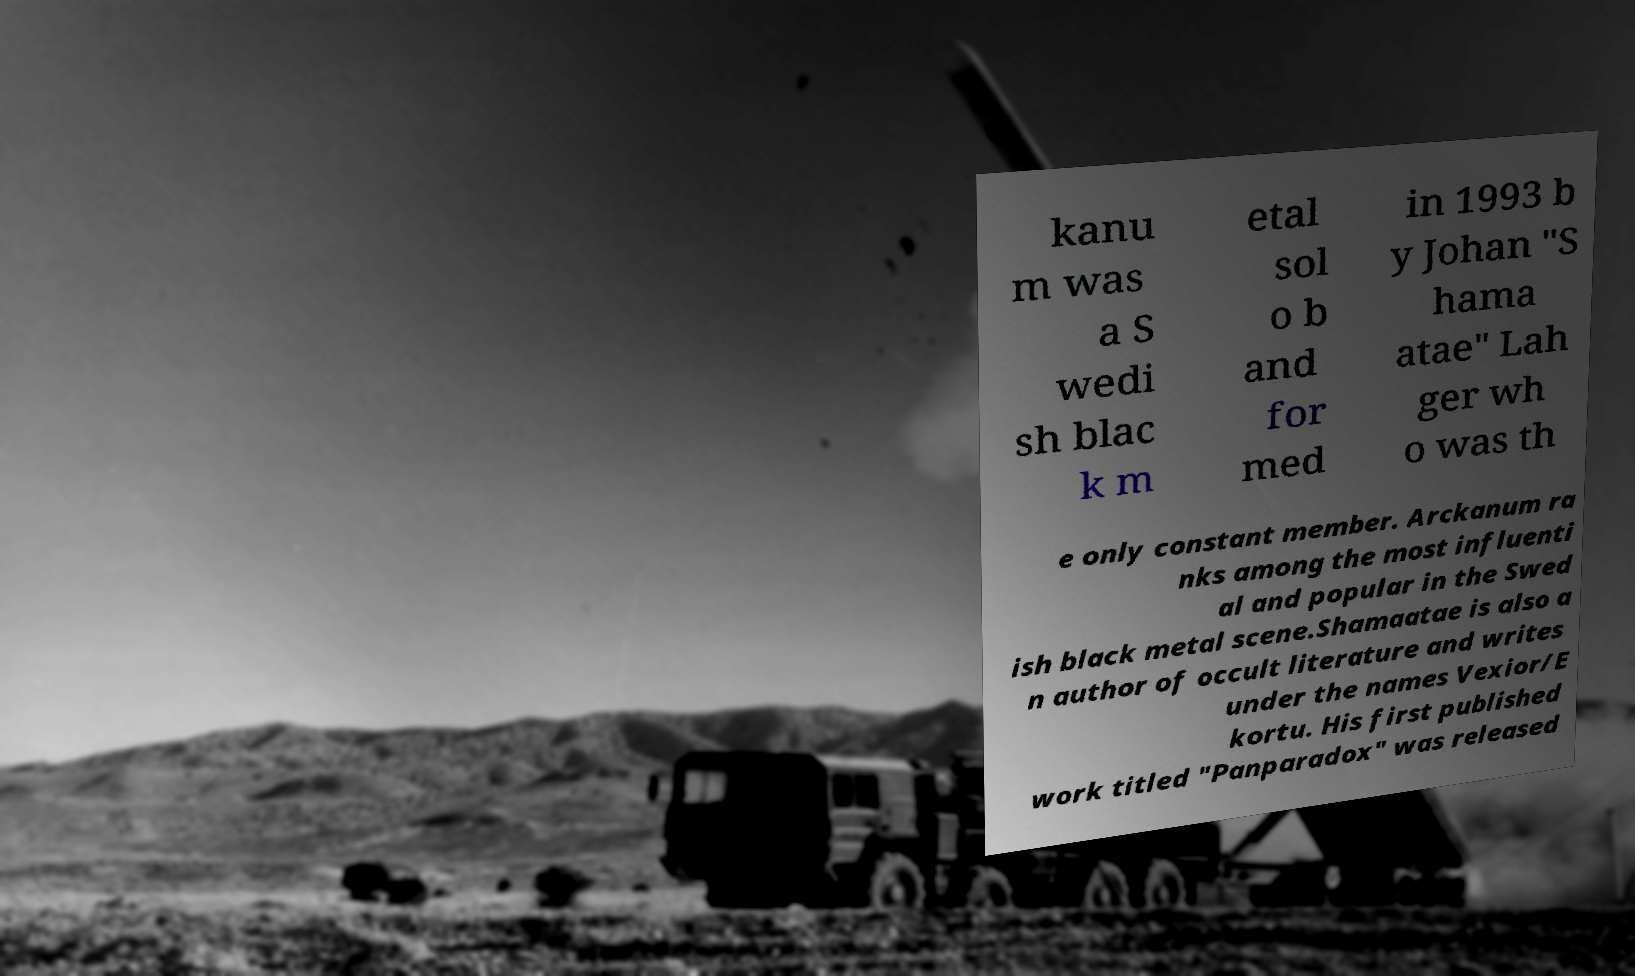Can you read and provide the text displayed in the image?This photo seems to have some interesting text. Can you extract and type it out for me? kanu m was a S wedi sh blac k m etal sol o b and for med in 1993 b y Johan "S hama atae" Lah ger wh o was th e only constant member. Arckanum ra nks among the most influenti al and popular in the Swed ish black metal scene.Shamaatae is also a n author of occult literature and writes under the names Vexior/E kortu. His first published work titled "Panparadox" was released 